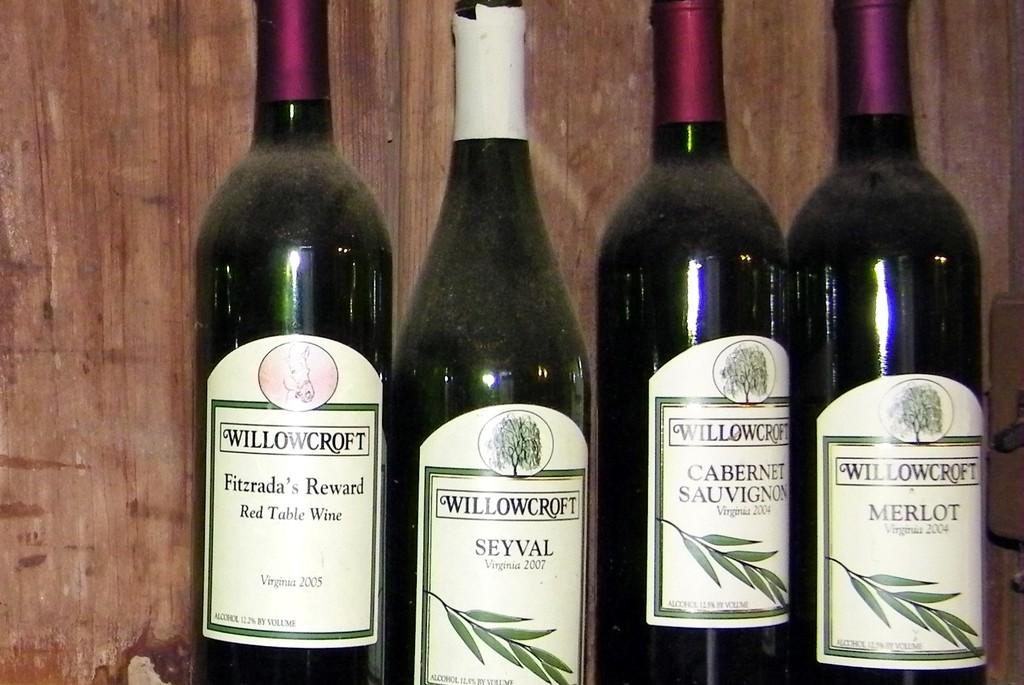What brand do these bottles of wine all share?
Offer a very short reply. Willowcroft. What year was the far left bottle made in?
Ensure brevity in your answer.  2005. 